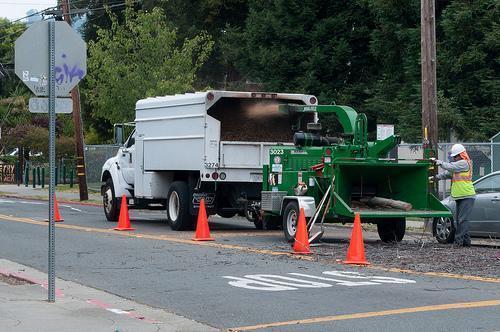How many orange cones are visible?
Give a very brief answer. 5. How many cars are shown?
Give a very brief answer. 1. How many workers can be counted?
Give a very brief answer. 1. How many animals are visible?
Give a very brief answer. 0. 